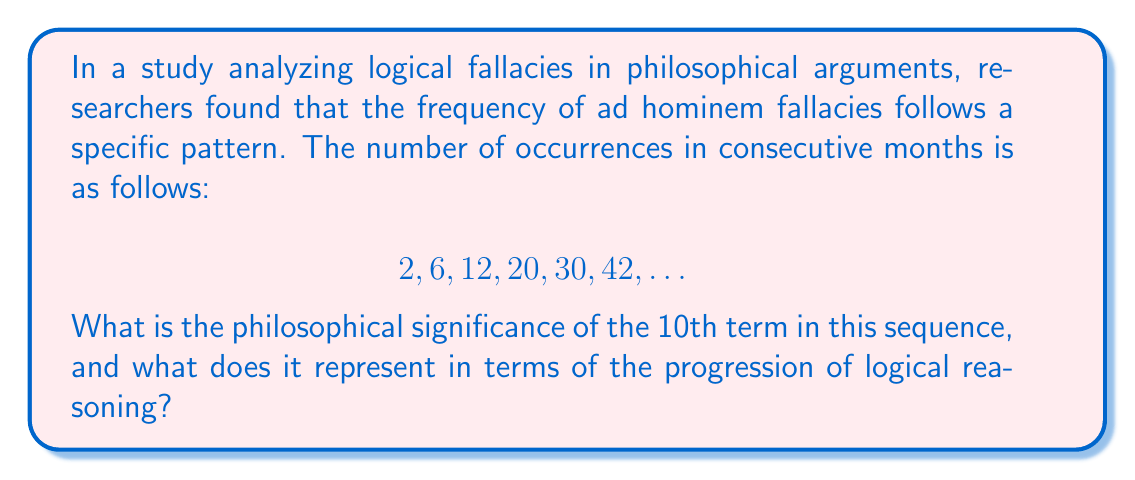Teach me how to tackle this problem. To solve this problem, we need to approach it both mathematically and philosophically:

1. First, let's analyze the numerical pattern:
   $2, 6, 12, 20, 30, 42, ...$

2. Calculate the differences between consecutive terms:
   $4, 6, 8, 10, 12, ...$

3. We observe that the differences form an arithmetic sequence with a common difference of 2.

4. The general formula for this type of sequence is:
   $a_n = \frac{n(n+1)}{2}$

   Where $a_n$ is the nth term and n is the position in the sequence.

5. To find the 10th term, we substitute n = 10:
   $a_{10} = \frac{10(10+1)}{2} = \frac{10 \times 11}{2} = 55$

6. Philosophical interpretation:
   The increasing frequency of ad hominem fallacies suggests a deterioration in the quality of logical reasoning over time. The 10th term, 55, represents a significant escalation in the use of this fallacy.

7. This pattern implies that as discussions progress, there's a tendency for arguments to become more personal and less focused on the actual issues, highlighting the importance of maintaining rigorous logical standards in philosophical discourse.

8. The quadratic nature of the sequence ($n(n+1)/2$) suggests an accelerating trend, which could be interpreted as a compounding effect where poor reasoning begets more poor reasoning.

9. From a philosophical standpoint, this pattern underscores the need for constant vigilance and education in logical reasoning to counteract the natural tendency towards fallacious argumentation.
Answer: 55; represents accelerating decline in logical reasoning quality 